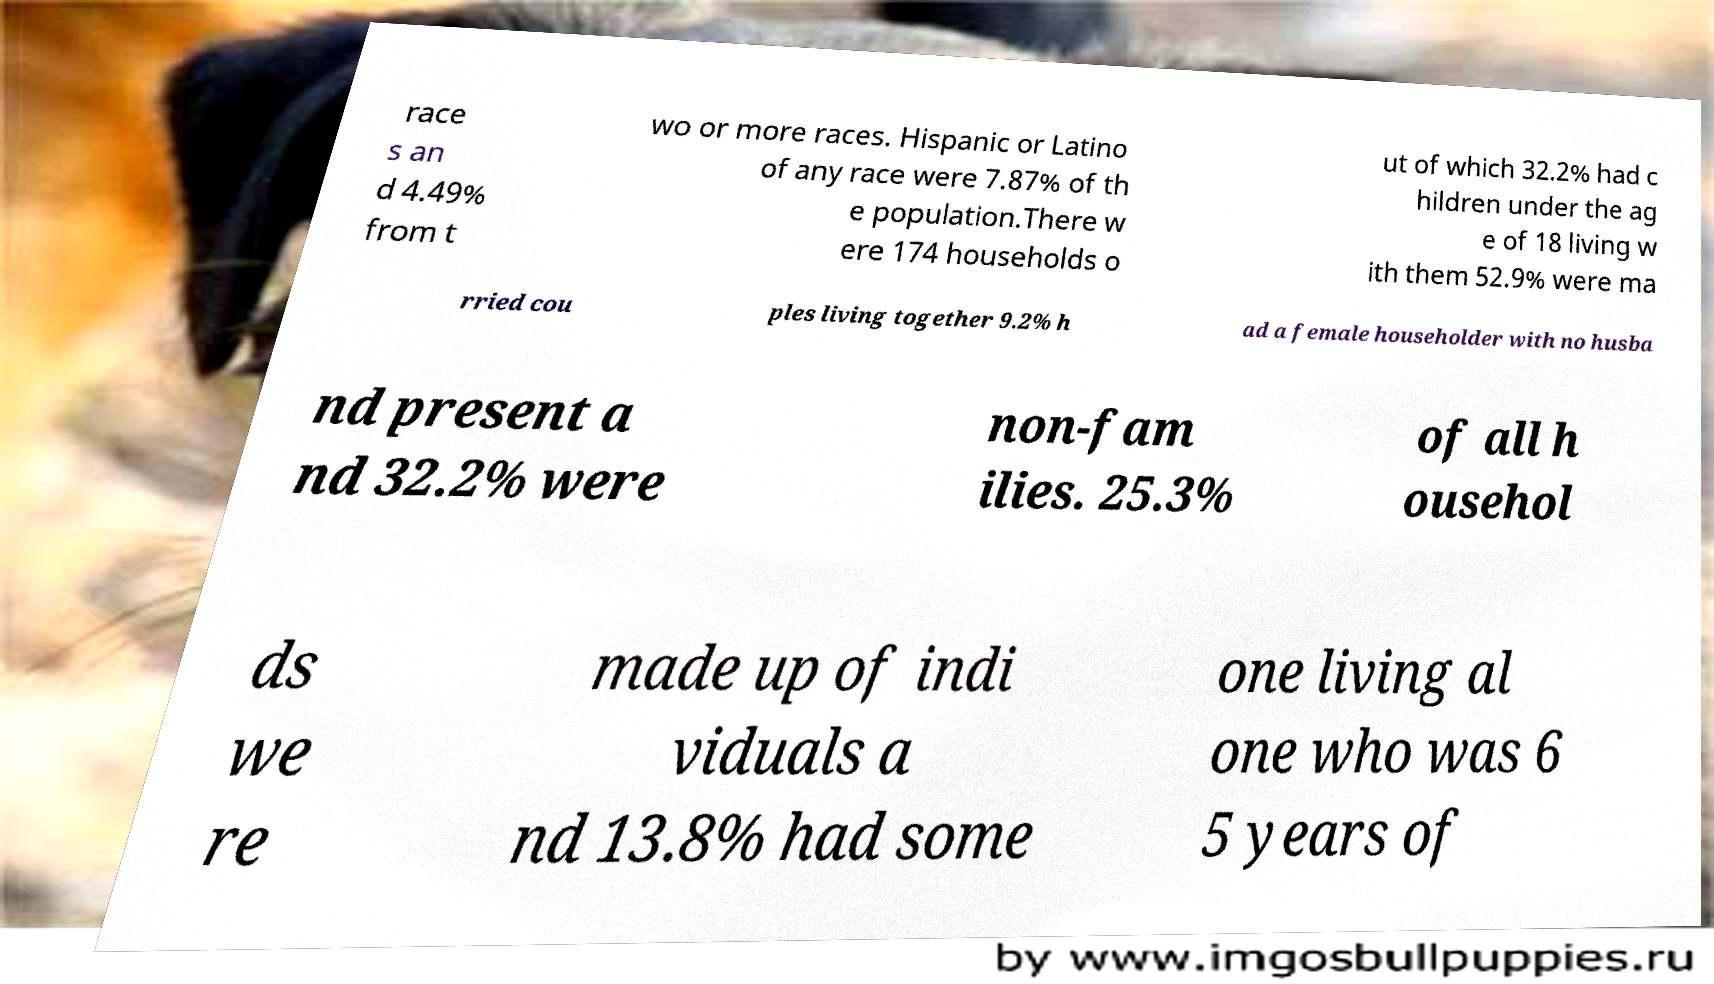There's text embedded in this image that I need extracted. Can you transcribe it verbatim? race s an d 4.49% from t wo or more races. Hispanic or Latino of any race were 7.87% of th e population.There w ere 174 households o ut of which 32.2% had c hildren under the ag e of 18 living w ith them 52.9% were ma rried cou ples living together 9.2% h ad a female householder with no husba nd present a nd 32.2% were non-fam ilies. 25.3% of all h ousehol ds we re made up of indi viduals a nd 13.8% had some one living al one who was 6 5 years of 